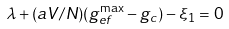<formula> <loc_0><loc_0><loc_500><loc_500>\lambda + ( a V / N ) ( g _ { e f } ^ { \max } - g _ { c } ) - \xi _ { 1 } = 0</formula> 